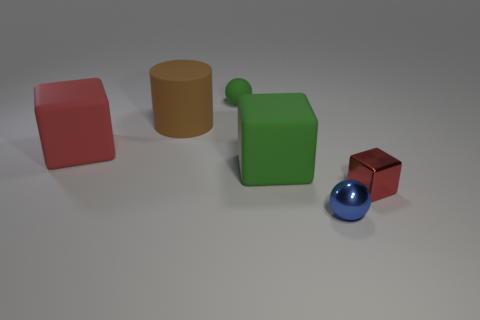Is there anything else that is the same shape as the brown object?
Provide a succinct answer. No. What color is the cube that is both on the right side of the red rubber thing and on the left side of the metal sphere?
Make the answer very short. Green. There is a rubber thing that is the same color as the tiny matte ball; what is its size?
Offer a terse response. Large. What number of big things are blue balls or brown metal objects?
Offer a very short reply. 0. Are there any other things that have the same color as the metal cube?
Ensure brevity in your answer.  Yes. What is the red thing that is in front of the object left of the big rubber object behind the red matte thing made of?
Your answer should be very brief. Metal. What number of matte things are blue objects or small red spheres?
Provide a succinct answer. 0. What number of yellow objects are large metallic cylinders or tiny blocks?
Make the answer very short. 0. Do the tiny ball that is right of the tiny matte thing and the small metal block have the same color?
Keep it short and to the point. No. Is the blue object made of the same material as the cylinder?
Your answer should be compact. No. 